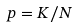<formula> <loc_0><loc_0><loc_500><loc_500>p = K / N</formula> 